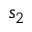<formula> <loc_0><loc_0><loc_500><loc_500>s _ { 2 }</formula> 